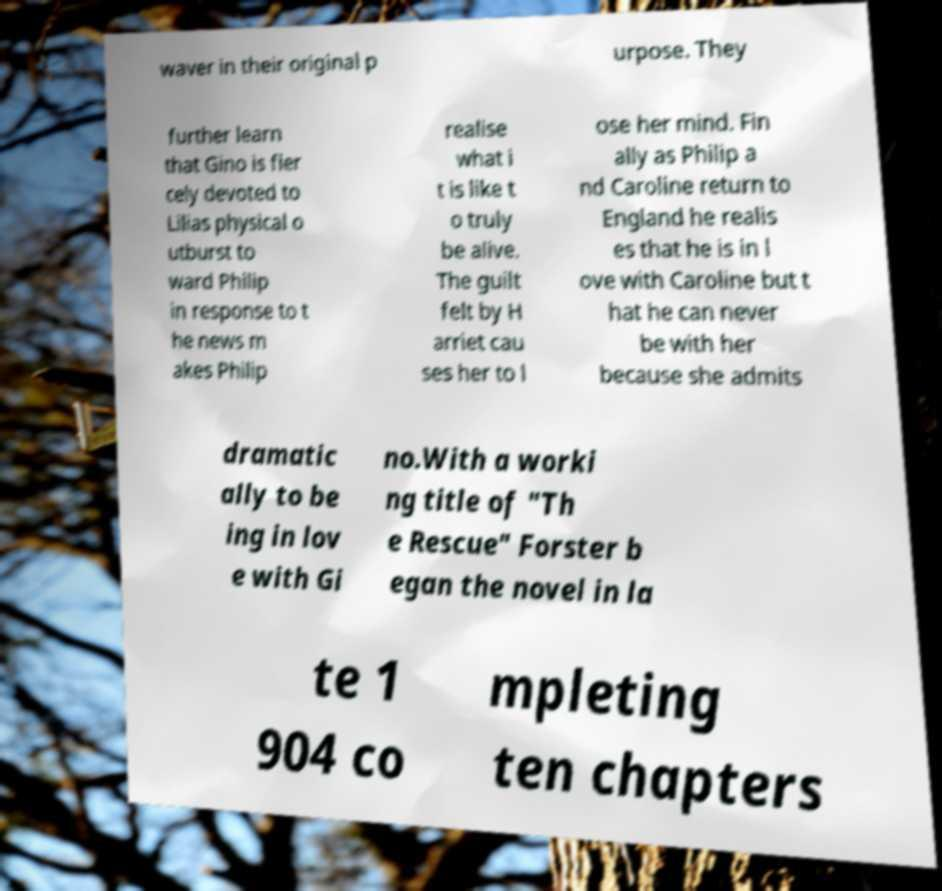Please read and relay the text visible in this image. What does it say? waver in their original p urpose. They further learn that Gino is fier cely devoted to Lilias physical o utburst to ward Philip in response to t he news m akes Philip realise what i t is like t o truly be alive. The guilt felt by H arriet cau ses her to l ose her mind. Fin ally as Philip a nd Caroline return to England he realis es that he is in l ove with Caroline but t hat he can never be with her because she admits dramatic ally to be ing in lov e with Gi no.With a worki ng title of "Th e Rescue" Forster b egan the novel in la te 1 904 co mpleting ten chapters 